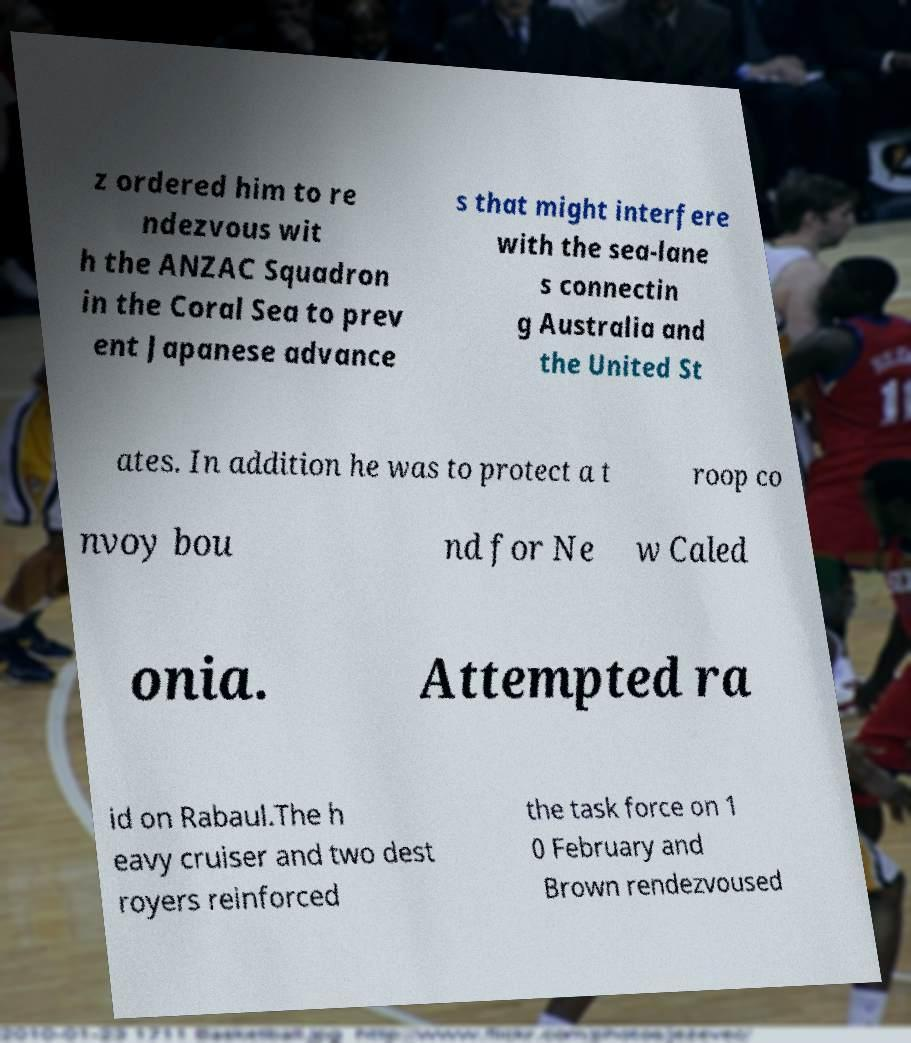Please identify and transcribe the text found in this image. z ordered him to re ndezvous wit h the ANZAC Squadron in the Coral Sea to prev ent Japanese advance s that might interfere with the sea-lane s connectin g Australia and the United St ates. In addition he was to protect a t roop co nvoy bou nd for Ne w Caled onia. Attempted ra id on Rabaul.The h eavy cruiser and two dest royers reinforced the task force on 1 0 February and Brown rendezvoused 